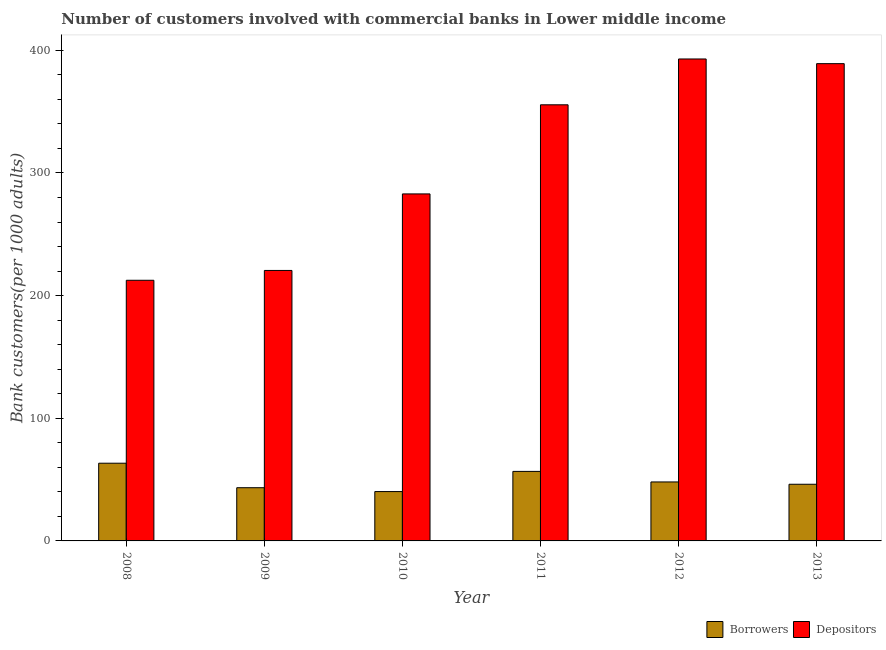How many groups of bars are there?
Your answer should be very brief. 6. How many bars are there on the 1st tick from the left?
Your answer should be very brief. 2. In how many cases, is the number of bars for a given year not equal to the number of legend labels?
Make the answer very short. 0. What is the number of borrowers in 2012?
Provide a short and direct response. 48.08. Across all years, what is the maximum number of depositors?
Provide a succinct answer. 392.92. Across all years, what is the minimum number of depositors?
Offer a terse response. 212.5. In which year was the number of borrowers maximum?
Your response must be concise. 2008. In which year was the number of borrowers minimum?
Provide a short and direct response. 2010. What is the total number of depositors in the graph?
Give a very brief answer. 1853.51. What is the difference between the number of borrowers in 2008 and that in 2012?
Provide a succinct answer. 15.28. What is the difference between the number of depositors in 2011 and the number of borrowers in 2012?
Keep it short and to the point. -37.36. What is the average number of borrowers per year?
Provide a short and direct response. 49.65. In how many years, is the number of borrowers greater than 100?
Your answer should be compact. 0. What is the ratio of the number of borrowers in 2009 to that in 2012?
Your answer should be compact. 0.9. What is the difference between the highest and the second highest number of borrowers?
Ensure brevity in your answer.  6.67. What is the difference between the highest and the lowest number of borrowers?
Offer a terse response. 23.13. In how many years, is the number of depositors greater than the average number of depositors taken over all years?
Offer a terse response. 3. Is the sum of the number of borrowers in 2009 and 2013 greater than the maximum number of depositors across all years?
Your answer should be very brief. Yes. What does the 2nd bar from the left in 2011 represents?
Keep it short and to the point. Depositors. What does the 1st bar from the right in 2009 represents?
Ensure brevity in your answer.  Depositors. How many bars are there?
Provide a short and direct response. 12. Are the values on the major ticks of Y-axis written in scientific E-notation?
Your response must be concise. No. Does the graph contain any zero values?
Provide a short and direct response. No. How many legend labels are there?
Ensure brevity in your answer.  2. How are the legend labels stacked?
Give a very brief answer. Horizontal. What is the title of the graph?
Keep it short and to the point. Number of customers involved with commercial banks in Lower middle income. Does "Secondary school" appear as one of the legend labels in the graph?
Your answer should be very brief. No. What is the label or title of the X-axis?
Give a very brief answer. Year. What is the label or title of the Y-axis?
Give a very brief answer. Bank customers(per 1000 adults). What is the Bank customers(per 1000 adults) of Borrowers in 2008?
Keep it short and to the point. 63.36. What is the Bank customers(per 1000 adults) of Depositors in 2008?
Your response must be concise. 212.5. What is the Bank customers(per 1000 adults) of Borrowers in 2009?
Keep it short and to the point. 43.38. What is the Bank customers(per 1000 adults) in Depositors in 2009?
Make the answer very short. 220.51. What is the Bank customers(per 1000 adults) in Borrowers in 2010?
Provide a succinct answer. 40.23. What is the Bank customers(per 1000 adults) of Depositors in 2010?
Your response must be concise. 282.91. What is the Bank customers(per 1000 adults) of Borrowers in 2011?
Provide a succinct answer. 56.68. What is the Bank customers(per 1000 adults) in Depositors in 2011?
Your answer should be very brief. 355.56. What is the Bank customers(per 1000 adults) in Borrowers in 2012?
Your response must be concise. 48.08. What is the Bank customers(per 1000 adults) in Depositors in 2012?
Your answer should be compact. 392.92. What is the Bank customers(per 1000 adults) of Borrowers in 2013?
Make the answer very short. 46.19. What is the Bank customers(per 1000 adults) of Depositors in 2013?
Give a very brief answer. 389.11. Across all years, what is the maximum Bank customers(per 1000 adults) of Borrowers?
Provide a short and direct response. 63.36. Across all years, what is the maximum Bank customers(per 1000 adults) in Depositors?
Offer a terse response. 392.92. Across all years, what is the minimum Bank customers(per 1000 adults) in Borrowers?
Your response must be concise. 40.23. Across all years, what is the minimum Bank customers(per 1000 adults) in Depositors?
Provide a succinct answer. 212.5. What is the total Bank customers(per 1000 adults) of Borrowers in the graph?
Give a very brief answer. 297.92. What is the total Bank customers(per 1000 adults) in Depositors in the graph?
Give a very brief answer. 1853.51. What is the difference between the Bank customers(per 1000 adults) of Borrowers in 2008 and that in 2009?
Keep it short and to the point. 19.98. What is the difference between the Bank customers(per 1000 adults) of Depositors in 2008 and that in 2009?
Make the answer very short. -8.01. What is the difference between the Bank customers(per 1000 adults) in Borrowers in 2008 and that in 2010?
Ensure brevity in your answer.  23.13. What is the difference between the Bank customers(per 1000 adults) in Depositors in 2008 and that in 2010?
Offer a very short reply. -70.41. What is the difference between the Bank customers(per 1000 adults) in Borrowers in 2008 and that in 2011?
Offer a very short reply. 6.67. What is the difference between the Bank customers(per 1000 adults) of Depositors in 2008 and that in 2011?
Provide a succinct answer. -143.06. What is the difference between the Bank customers(per 1000 adults) in Borrowers in 2008 and that in 2012?
Offer a very short reply. 15.28. What is the difference between the Bank customers(per 1000 adults) of Depositors in 2008 and that in 2012?
Ensure brevity in your answer.  -180.42. What is the difference between the Bank customers(per 1000 adults) of Borrowers in 2008 and that in 2013?
Make the answer very short. 17.17. What is the difference between the Bank customers(per 1000 adults) in Depositors in 2008 and that in 2013?
Your response must be concise. -176.6. What is the difference between the Bank customers(per 1000 adults) in Borrowers in 2009 and that in 2010?
Your answer should be very brief. 3.15. What is the difference between the Bank customers(per 1000 adults) in Depositors in 2009 and that in 2010?
Your answer should be very brief. -62.4. What is the difference between the Bank customers(per 1000 adults) in Borrowers in 2009 and that in 2011?
Offer a terse response. -13.31. What is the difference between the Bank customers(per 1000 adults) in Depositors in 2009 and that in 2011?
Your answer should be compact. -135.05. What is the difference between the Bank customers(per 1000 adults) of Borrowers in 2009 and that in 2012?
Your answer should be compact. -4.7. What is the difference between the Bank customers(per 1000 adults) in Depositors in 2009 and that in 2012?
Offer a terse response. -172.41. What is the difference between the Bank customers(per 1000 adults) in Borrowers in 2009 and that in 2013?
Offer a terse response. -2.81. What is the difference between the Bank customers(per 1000 adults) in Depositors in 2009 and that in 2013?
Ensure brevity in your answer.  -168.6. What is the difference between the Bank customers(per 1000 adults) of Borrowers in 2010 and that in 2011?
Make the answer very short. -16.45. What is the difference between the Bank customers(per 1000 adults) of Depositors in 2010 and that in 2011?
Your answer should be very brief. -72.64. What is the difference between the Bank customers(per 1000 adults) of Borrowers in 2010 and that in 2012?
Provide a short and direct response. -7.85. What is the difference between the Bank customers(per 1000 adults) in Depositors in 2010 and that in 2012?
Offer a terse response. -110.01. What is the difference between the Bank customers(per 1000 adults) in Borrowers in 2010 and that in 2013?
Your response must be concise. -5.96. What is the difference between the Bank customers(per 1000 adults) in Depositors in 2010 and that in 2013?
Make the answer very short. -106.19. What is the difference between the Bank customers(per 1000 adults) in Borrowers in 2011 and that in 2012?
Give a very brief answer. 8.61. What is the difference between the Bank customers(per 1000 adults) in Depositors in 2011 and that in 2012?
Offer a very short reply. -37.36. What is the difference between the Bank customers(per 1000 adults) of Borrowers in 2011 and that in 2013?
Make the answer very short. 10.49. What is the difference between the Bank customers(per 1000 adults) in Depositors in 2011 and that in 2013?
Provide a short and direct response. -33.55. What is the difference between the Bank customers(per 1000 adults) in Borrowers in 2012 and that in 2013?
Offer a very short reply. 1.89. What is the difference between the Bank customers(per 1000 adults) of Depositors in 2012 and that in 2013?
Your response must be concise. 3.82. What is the difference between the Bank customers(per 1000 adults) in Borrowers in 2008 and the Bank customers(per 1000 adults) in Depositors in 2009?
Your answer should be compact. -157.15. What is the difference between the Bank customers(per 1000 adults) in Borrowers in 2008 and the Bank customers(per 1000 adults) in Depositors in 2010?
Keep it short and to the point. -219.55. What is the difference between the Bank customers(per 1000 adults) in Borrowers in 2008 and the Bank customers(per 1000 adults) in Depositors in 2011?
Offer a terse response. -292.2. What is the difference between the Bank customers(per 1000 adults) of Borrowers in 2008 and the Bank customers(per 1000 adults) of Depositors in 2012?
Provide a succinct answer. -329.56. What is the difference between the Bank customers(per 1000 adults) in Borrowers in 2008 and the Bank customers(per 1000 adults) in Depositors in 2013?
Give a very brief answer. -325.75. What is the difference between the Bank customers(per 1000 adults) of Borrowers in 2009 and the Bank customers(per 1000 adults) of Depositors in 2010?
Make the answer very short. -239.53. What is the difference between the Bank customers(per 1000 adults) of Borrowers in 2009 and the Bank customers(per 1000 adults) of Depositors in 2011?
Provide a succinct answer. -312.18. What is the difference between the Bank customers(per 1000 adults) of Borrowers in 2009 and the Bank customers(per 1000 adults) of Depositors in 2012?
Ensure brevity in your answer.  -349.54. What is the difference between the Bank customers(per 1000 adults) of Borrowers in 2009 and the Bank customers(per 1000 adults) of Depositors in 2013?
Offer a very short reply. -345.73. What is the difference between the Bank customers(per 1000 adults) of Borrowers in 2010 and the Bank customers(per 1000 adults) of Depositors in 2011?
Your response must be concise. -315.33. What is the difference between the Bank customers(per 1000 adults) of Borrowers in 2010 and the Bank customers(per 1000 adults) of Depositors in 2012?
Keep it short and to the point. -352.69. What is the difference between the Bank customers(per 1000 adults) in Borrowers in 2010 and the Bank customers(per 1000 adults) in Depositors in 2013?
Your response must be concise. -348.88. What is the difference between the Bank customers(per 1000 adults) in Borrowers in 2011 and the Bank customers(per 1000 adults) in Depositors in 2012?
Provide a short and direct response. -336.24. What is the difference between the Bank customers(per 1000 adults) in Borrowers in 2011 and the Bank customers(per 1000 adults) in Depositors in 2013?
Provide a succinct answer. -332.42. What is the difference between the Bank customers(per 1000 adults) of Borrowers in 2012 and the Bank customers(per 1000 adults) of Depositors in 2013?
Make the answer very short. -341.03. What is the average Bank customers(per 1000 adults) of Borrowers per year?
Offer a very short reply. 49.65. What is the average Bank customers(per 1000 adults) in Depositors per year?
Provide a short and direct response. 308.92. In the year 2008, what is the difference between the Bank customers(per 1000 adults) in Borrowers and Bank customers(per 1000 adults) in Depositors?
Offer a terse response. -149.14. In the year 2009, what is the difference between the Bank customers(per 1000 adults) of Borrowers and Bank customers(per 1000 adults) of Depositors?
Your answer should be very brief. -177.13. In the year 2010, what is the difference between the Bank customers(per 1000 adults) of Borrowers and Bank customers(per 1000 adults) of Depositors?
Make the answer very short. -242.68. In the year 2011, what is the difference between the Bank customers(per 1000 adults) of Borrowers and Bank customers(per 1000 adults) of Depositors?
Provide a short and direct response. -298.87. In the year 2012, what is the difference between the Bank customers(per 1000 adults) in Borrowers and Bank customers(per 1000 adults) in Depositors?
Provide a short and direct response. -344.84. In the year 2013, what is the difference between the Bank customers(per 1000 adults) in Borrowers and Bank customers(per 1000 adults) in Depositors?
Offer a very short reply. -342.91. What is the ratio of the Bank customers(per 1000 adults) of Borrowers in 2008 to that in 2009?
Ensure brevity in your answer.  1.46. What is the ratio of the Bank customers(per 1000 adults) in Depositors in 2008 to that in 2009?
Ensure brevity in your answer.  0.96. What is the ratio of the Bank customers(per 1000 adults) of Borrowers in 2008 to that in 2010?
Give a very brief answer. 1.57. What is the ratio of the Bank customers(per 1000 adults) of Depositors in 2008 to that in 2010?
Make the answer very short. 0.75. What is the ratio of the Bank customers(per 1000 adults) of Borrowers in 2008 to that in 2011?
Your answer should be compact. 1.12. What is the ratio of the Bank customers(per 1000 adults) in Depositors in 2008 to that in 2011?
Give a very brief answer. 0.6. What is the ratio of the Bank customers(per 1000 adults) in Borrowers in 2008 to that in 2012?
Offer a very short reply. 1.32. What is the ratio of the Bank customers(per 1000 adults) in Depositors in 2008 to that in 2012?
Make the answer very short. 0.54. What is the ratio of the Bank customers(per 1000 adults) of Borrowers in 2008 to that in 2013?
Offer a very short reply. 1.37. What is the ratio of the Bank customers(per 1000 adults) in Depositors in 2008 to that in 2013?
Ensure brevity in your answer.  0.55. What is the ratio of the Bank customers(per 1000 adults) of Borrowers in 2009 to that in 2010?
Your answer should be compact. 1.08. What is the ratio of the Bank customers(per 1000 adults) of Depositors in 2009 to that in 2010?
Give a very brief answer. 0.78. What is the ratio of the Bank customers(per 1000 adults) in Borrowers in 2009 to that in 2011?
Give a very brief answer. 0.77. What is the ratio of the Bank customers(per 1000 adults) in Depositors in 2009 to that in 2011?
Keep it short and to the point. 0.62. What is the ratio of the Bank customers(per 1000 adults) of Borrowers in 2009 to that in 2012?
Offer a terse response. 0.9. What is the ratio of the Bank customers(per 1000 adults) of Depositors in 2009 to that in 2012?
Offer a very short reply. 0.56. What is the ratio of the Bank customers(per 1000 adults) in Borrowers in 2009 to that in 2013?
Your answer should be very brief. 0.94. What is the ratio of the Bank customers(per 1000 adults) of Depositors in 2009 to that in 2013?
Offer a terse response. 0.57. What is the ratio of the Bank customers(per 1000 adults) of Borrowers in 2010 to that in 2011?
Provide a short and direct response. 0.71. What is the ratio of the Bank customers(per 1000 adults) of Depositors in 2010 to that in 2011?
Give a very brief answer. 0.8. What is the ratio of the Bank customers(per 1000 adults) in Borrowers in 2010 to that in 2012?
Your response must be concise. 0.84. What is the ratio of the Bank customers(per 1000 adults) in Depositors in 2010 to that in 2012?
Your response must be concise. 0.72. What is the ratio of the Bank customers(per 1000 adults) in Borrowers in 2010 to that in 2013?
Your answer should be very brief. 0.87. What is the ratio of the Bank customers(per 1000 adults) of Depositors in 2010 to that in 2013?
Your answer should be very brief. 0.73. What is the ratio of the Bank customers(per 1000 adults) of Borrowers in 2011 to that in 2012?
Provide a succinct answer. 1.18. What is the ratio of the Bank customers(per 1000 adults) of Depositors in 2011 to that in 2012?
Offer a very short reply. 0.9. What is the ratio of the Bank customers(per 1000 adults) of Borrowers in 2011 to that in 2013?
Ensure brevity in your answer.  1.23. What is the ratio of the Bank customers(per 1000 adults) in Depositors in 2011 to that in 2013?
Give a very brief answer. 0.91. What is the ratio of the Bank customers(per 1000 adults) of Borrowers in 2012 to that in 2013?
Keep it short and to the point. 1.04. What is the ratio of the Bank customers(per 1000 adults) in Depositors in 2012 to that in 2013?
Give a very brief answer. 1.01. What is the difference between the highest and the second highest Bank customers(per 1000 adults) in Borrowers?
Make the answer very short. 6.67. What is the difference between the highest and the second highest Bank customers(per 1000 adults) of Depositors?
Offer a very short reply. 3.82. What is the difference between the highest and the lowest Bank customers(per 1000 adults) in Borrowers?
Give a very brief answer. 23.13. What is the difference between the highest and the lowest Bank customers(per 1000 adults) of Depositors?
Your answer should be compact. 180.42. 